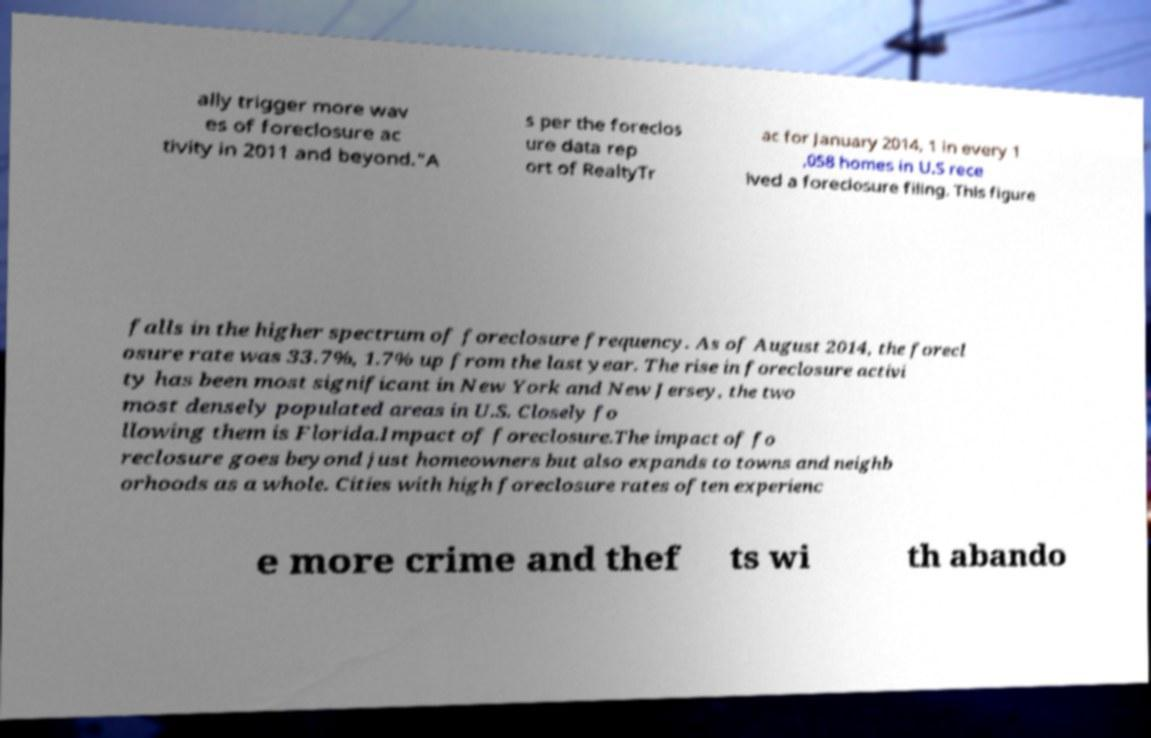For documentation purposes, I need the text within this image transcribed. Could you provide that? ally trigger more wav es of foreclosure ac tivity in 2011 and beyond.”A s per the foreclos ure data rep ort of RealtyTr ac for January 2014, 1 in every 1 ,058 homes in U.S rece ived a foreclosure filing. This figure falls in the higher spectrum of foreclosure frequency. As of August 2014, the forecl osure rate was 33.7%, 1.7% up from the last year. The rise in foreclosure activi ty has been most significant in New York and New Jersey, the two most densely populated areas in U.S. Closely fo llowing them is Florida.Impact of foreclosure.The impact of fo reclosure goes beyond just homeowners but also expands to towns and neighb orhoods as a whole. Cities with high foreclosure rates often experienc e more crime and thef ts wi th abando 